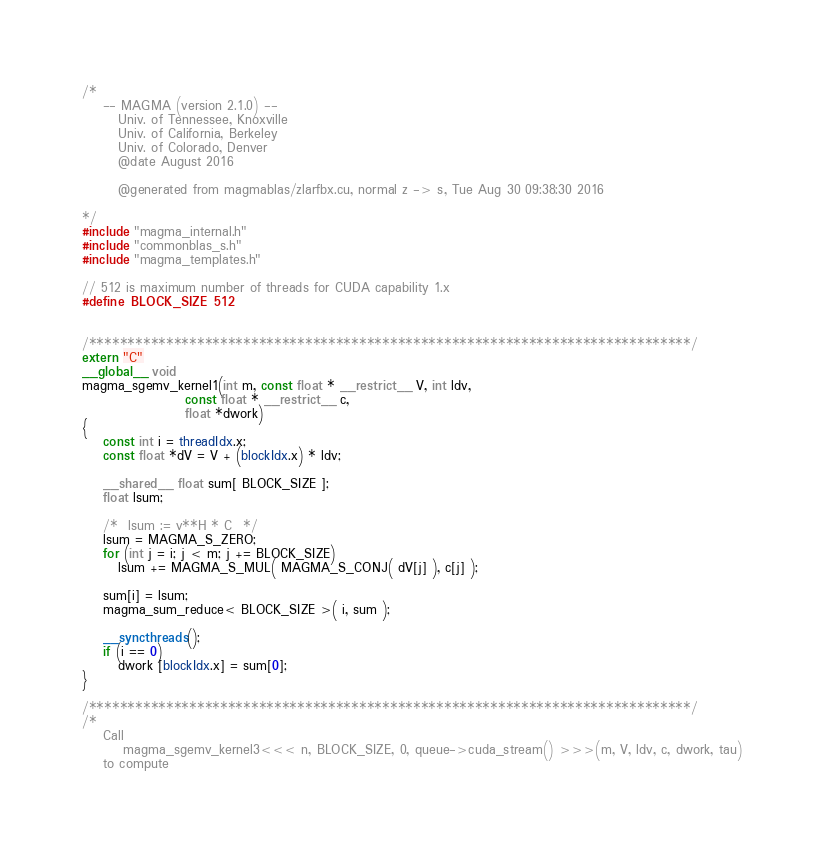Convert code to text. <code><loc_0><loc_0><loc_500><loc_500><_Cuda_>/*
    -- MAGMA (version 2.1.0) --
       Univ. of Tennessee, Knoxville
       Univ. of California, Berkeley
       Univ. of Colorado, Denver
       @date August 2016

       @generated from magmablas/zlarfbx.cu, normal z -> s, Tue Aug 30 09:38:30 2016

*/
#include "magma_internal.h"
#include "commonblas_s.h"
#include "magma_templates.h"

// 512 is maximum number of threads for CUDA capability 1.x
#define BLOCK_SIZE 512


/******************************************************************************/
extern "C"
__global__ void 
magma_sgemv_kernel1(int m, const float * __restrict__ V, int ldv, 
                    const float * __restrict__ c, 
                    float *dwork)
{
    const int i = threadIdx.x;
    const float *dV = V + (blockIdx.x) * ldv;

    __shared__ float sum[ BLOCK_SIZE ];
    float lsum;

    /*  lsum := v**H * C  */
    lsum = MAGMA_S_ZERO;
    for (int j = i; j < m; j += BLOCK_SIZE)
       lsum += MAGMA_S_MUL( MAGMA_S_CONJ( dV[j] ), c[j] );
    
    sum[i] = lsum;
    magma_sum_reduce< BLOCK_SIZE >( i, sum );

    __syncthreads();
    if (i == 0)
       dwork [blockIdx.x] = sum[0];
}

/******************************************************************************/
/*
    Call 
        magma_sgemv_kernel3<<< n, BLOCK_SIZE, 0, queue->cuda_stream() >>>(m, V, ldv, c, dwork, tau)
    to compute</code> 